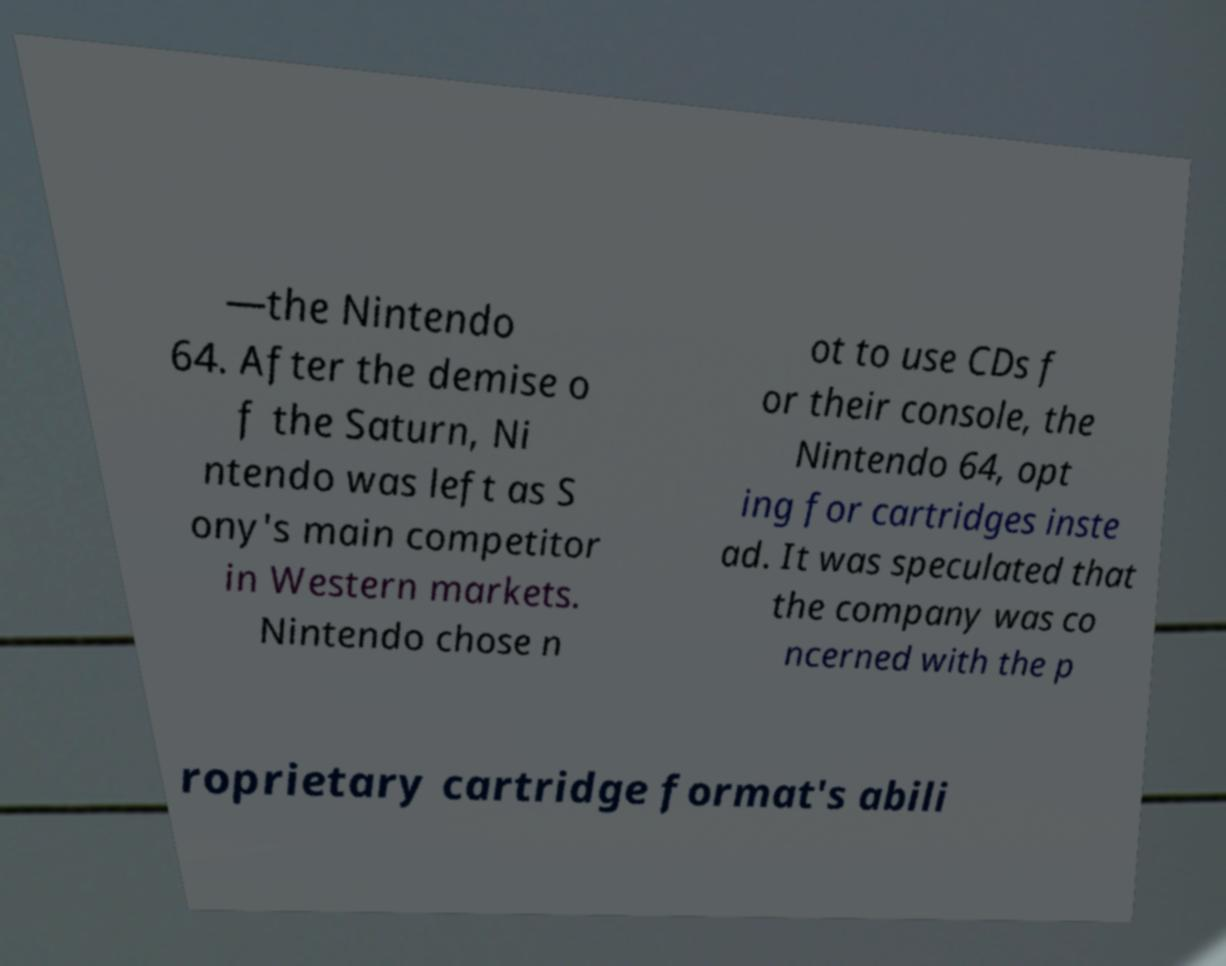Can you accurately transcribe the text from the provided image for me? —the Nintendo 64. After the demise o f the Saturn, Ni ntendo was left as S ony's main competitor in Western markets. Nintendo chose n ot to use CDs f or their console, the Nintendo 64, opt ing for cartridges inste ad. It was speculated that the company was co ncerned with the p roprietary cartridge format's abili 